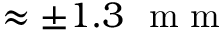<formula> <loc_0><loc_0><loc_500><loc_500>\approx \pm 1 . 3 m m</formula> 